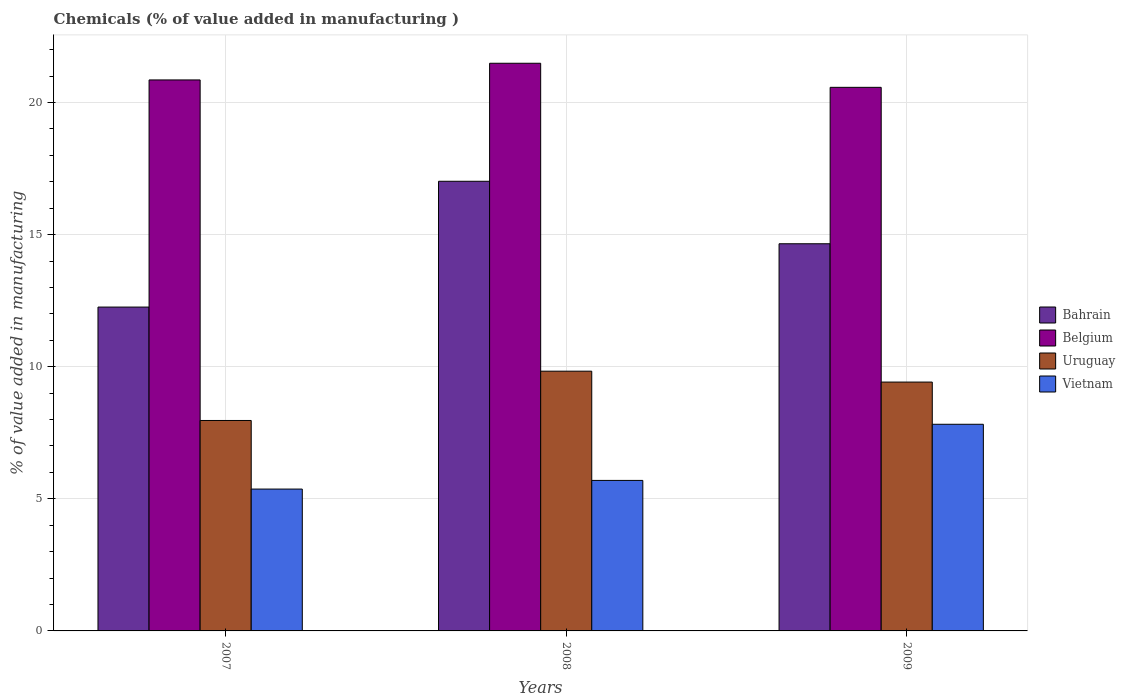How many groups of bars are there?
Your response must be concise. 3. Are the number of bars on each tick of the X-axis equal?
Keep it short and to the point. Yes. How many bars are there on the 1st tick from the left?
Keep it short and to the point. 4. What is the label of the 3rd group of bars from the left?
Offer a very short reply. 2009. What is the value added in manufacturing chemicals in Belgium in 2008?
Ensure brevity in your answer.  21.49. Across all years, what is the maximum value added in manufacturing chemicals in Vietnam?
Offer a very short reply. 7.82. Across all years, what is the minimum value added in manufacturing chemicals in Uruguay?
Your answer should be compact. 7.97. What is the total value added in manufacturing chemicals in Vietnam in the graph?
Offer a terse response. 18.89. What is the difference between the value added in manufacturing chemicals in Bahrain in 2008 and that in 2009?
Give a very brief answer. 2.36. What is the difference between the value added in manufacturing chemicals in Uruguay in 2008 and the value added in manufacturing chemicals in Vietnam in 2007?
Your answer should be compact. 4.46. What is the average value added in manufacturing chemicals in Vietnam per year?
Ensure brevity in your answer.  6.3. In the year 2009, what is the difference between the value added in manufacturing chemicals in Belgium and value added in manufacturing chemicals in Bahrain?
Offer a very short reply. 5.92. In how many years, is the value added in manufacturing chemicals in Bahrain greater than 15 %?
Make the answer very short. 1. What is the ratio of the value added in manufacturing chemicals in Vietnam in 2007 to that in 2009?
Ensure brevity in your answer.  0.69. What is the difference between the highest and the second highest value added in manufacturing chemicals in Vietnam?
Give a very brief answer. 2.13. What is the difference between the highest and the lowest value added in manufacturing chemicals in Belgium?
Give a very brief answer. 0.91. In how many years, is the value added in manufacturing chemicals in Vietnam greater than the average value added in manufacturing chemicals in Vietnam taken over all years?
Provide a succinct answer. 1. What does the 3rd bar from the left in 2007 represents?
Provide a short and direct response. Uruguay. How many bars are there?
Offer a terse response. 12. Are all the bars in the graph horizontal?
Your answer should be compact. No. What is the difference between two consecutive major ticks on the Y-axis?
Provide a succinct answer. 5. Are the values on the major ticks of Y-axis written in scientific E-notation?
Ensure brevity in your answer.  No. Does the graph contain any zero values?
Provide a succinct answer. No. Does the graph contain grids?
Your response must be concise. Yes. Where does the legend appear in the graph?
Keep it short and to the point. Center right. How many legend labels are there?
Your answer should be compact. 4. How are the legend labels stacked?
Provide a succinct answer. Vertical. What is the title of the graph?
Offer a terse response. Chemicals (% of value added in manufacturing ). Does "Chad" appear as one of the legend labels in the graph?
Provide a succinct answer. No. What is the label or title of the Y-axis?
Offer a very short reply. % of value added in manufacturing. What is the % of value added in manufacturing in Bahrain in 2007?
Offer a terse response. 12.26. What is the % of value added in manufacturing in Belgium in 2007?
Keep it short and to the point. 20.86. What is the % of value added in manufacturing in Uruguay in 2007?
Your answer should be compact. 7.97. What is the % of value added in manufacturing in Vietnam in 2007?
Your answer should be compact. 5.37. What is the % of value added in manufacturing of Bahrain in 2008?
Your answer should be very brief. 17.02. What is the % of value added in manufacturing in Belgium in 2008?
Provide a succinct answer. 21.49. What is the % of value added in manufacturing in Uruguay in 2008?
Make the answer very short. 9.83. What is the % of value added in manufacturing in Vietnam in 2008?
Your answer should be compact. 5.7. What is the % of value added in manufacturing of Bahrain in 2009?
Provide a succinct answer. 14.65. What is the % of value added in manufacturing in Belgium in 2009?
Give a very brief answer. 20.58. What is the % of value added in manufacturing of Uruguay in 2009?
Keep it short and to the point. 9.42. What is the % of value added in manufacturing of Vietnam in 2009?
Offer a very short reply. 7.82. Across all years, what is the maximum % of value added in manufacturing in Bahrain?
Keep it short and to the point. 17.02. Across all years, what is the maximum % of value added in manufacturing of Belgium?
Keep it short and to the point. 21.49. Across all years, what is the maximum % of value added in manufacturing of Uruguay?
Your answer should be compact. 9.83. Across all years, what is the maximum % of value added in manufacturing in Vietnam?
Ensure brevity in your answer.  7.82. Across all years, what is the minimum % of value added in manufacturing of Bahrain?
Your response must be concise. 12.26. Across all years, what is the minimum % of value added in manufacturing of Belgium?
Make the answer very short. 20.58. Across all years, what is the minimum % of value added in manufacturing of Uruguay?
Keep it short and to the point. 7.97. Across all years, what is the minimum % of value added in manufacturing in Vietnam?
Provide a short and direct response. 5.37. What is the total % of value added in manufacturing in Bahrain in the graph?
Ensure brevity in your answer.  43.93. What is the total % of value added in manufacturing in Belgium in the graph?
Provide a short and direct response. 62.92. What is the total % of value added in manufacturing in Uruguay in the graph?
Make the answer very short. 27.22. What is the total % of value added in manufacturing of Vietnam in the graph?
Make the answer very short. 18.89. What is the difference between the % of value added in manufacturing in Bahrain in 2007 and that in 2008?
Keep it short and to the point. -4.76. What is the difference between the % of value added in manufacturing of Belgium in 2007 and that in 2008?
Give a very brief answer. -0.63. What is the difference between the % of value added in manufacturing in Uruguay in 2007 and that in 2008?
Ensure brevity in your answer.  -1.87. What is the difference between the % of value added in manufacturing in Vietnam in 2007 and that in 2008?
Provide a succinct answer. -0.33. What is the difference between the % of value added in manufacturing in Bahrain in 2007 and that in 2009?
Provide a short and direct response. -2.4. What is the difference between the % of value added in manufacturing of Belgium in 2007 and that in 2009?
Make the answer very short. 0.28. What is the difference between the % of value added in manufacturing of Uruguay in 2007 and that in 2009?
Ensure brevity in your answer.  -1.45. What is the difference between the % of value added in manufacturing of Vietnam in 2007 and that in 2009?
Ensure brevity in your answer.  -2.45. What is the difference between the % of value added in manufacturing in Bahrain in 2008 and that in 2009?
Your response must be concise. 2.36. What is the difference between the % of value added in manufacturing in Belgium in 2008 and that in 2009?
Your answer should be very brief. 0.91. What is the difference between the % of value added in manufacturing in Uruguay in 2008 and that in 2009?
Provide a succinct answer. 0.41. What is the difference between the % of value added in manufacturing of Vietnam in 2008 and that in 2009?
Offer a very short reply. -2.13. What is the difference between the % of value added in manufacturing in Bahrain in 2007 and the % of value added in manufacturing in Belgium in 2008?
Your answer should be very brief. -9.23. What is the difference between the % of value added in manufacturing in Bahrain in 2007 and the % of value added in manufacturing in Uruguay in 2008?
Give a very brief answer. 2.43. What is the difference between the % of value added in manufacturing of Bahrain in 2007 and the % of value added in manufacturing of Vietnam in 2008?
Keep it short and to the point. 6.56. What is the difference between the % of value added in manufacturing in Belgium in 2007 and the % of value added in manufacturing in Uruguay in 2008?
Your answer should be very brief. 11.02. What is the difference between the % of value added in manufacturing of Belgium in 2007 and the % of value added in manufacturing of Vietnam in 2008?
Your answer should be very brief. 15.16. What is the difference between the % of value added in manufacturing in Uruguay in 2007 and the % of value added in manufacturing in Vietnam in 2008?
Your answer should be compact. 2.27. What is the difference between the % of value added in manufacturing in Bahrain in 2007 and the % of value added in manufacturing in Belgium in 2009?
Keep it short and to the point. -8.32. What is the difference between the % of value added in manufacturing of Bahrain in 2007 and the % of value added in manufacturing of Uruguay in 2009?
Your answer should be very brief. 2.84. What is the difference between the % of value added in manufacturing of Bahrain in 2007 and the % of value added in manufacturing of Vietnam in 2009?
Offer a very short reply. 4.44. What is the difference between the % of value added in manufacturing of Belgium in 2007 and the % of value added in manufacturing of Uruguay in 2009?
Your answer should be compact. 11.44. What is the difference between the % of value added in manufacturing of Belgium in 2007 and the % of value added in manufacturing of Vietnam in 2009?
Your answer should be compact. 13.03. What is the difference between the % of value added in manufacturing in Uruguay in 2007 and the % of value added in manufacturing in Vietnam in 2009?
Provide a short and direct response. 0.14. What is the difference between the % of value added in manufacturing of Bahrain in 2008 and the % of value added in manufacturing of Belgium in 2009?
Keep it short and to the point. -3.56. What is the difference between the % of value added in manufacturing in Bahrain in 2008 and the % of value added in manufacturing in Uruguay in 2009?
Keep it short and to the point. 7.6. What is the difference between the % of value added in manufacturing of Bahrain in 2008 and the % of value added in manufacturing of Vietnam in 2009?
Give a very brief answer. 9.2. What is the difference between the % of value added in manufacturing in Belgium in 2008 and the % of value added in manufacturing in Uruguay in 2009?
Keep it short and to the point. 12.07. What is the difference between the % of value added in manufacturing in Belgium in 2008 and the % of value added in manufacturing in Vietnam in 2009?
Your answer should be very brief. 13.66. What is the difference between the % of value added in manufacturing in Uruguay in 2008 and the % of value added in manufacturing in Vietnam in 2009?
Give a very brief answer. 2.01. What is the average % of value added in manufacturing of Bahrain per year?
Your answer should be very brief. 14.64. What is the average % of value added in manufacturing of Belgium per year?
Offer a terse response. 20.97. What is the average % of value added in manufacturing in Uruguay per year?
Your answer should be very brief. 9.07. What is the average % of value added in manufacturing in Vietnam per year?
Make the answer very short. 6.3. In the year 2007, what is the difference between the % of value added in manufacturing of Bahrain and % of value added in manufacturing of Belgium?
Your answer should be very brief. -8.6. In the year 2007, what is the difference between the % of value added in manufacturing in Bahrain and % of value added in manufacturing in Uruguay?
Give a very brief answer. 4.29. In the year 2007, what is the difference between the % of value added in manufacturing in Bahrain and % of value added in manufacturing in Vietnam?
Your response must be concise. 6.89. In the year 2007, what is the difference between the % of value added in manufacturing in Belgium and % of value added in manufacturing in Uruguay?
Your answer should be compact. 12.89. In the year 2007, what is the difference between the % of value added in manufacturing of Belgium and % of value added in manufacturing of Vietnam?
Ensure brevity in your answer.  15.49. In the year 2007, what is the difference between the % of value added in manufacturing in Uruguay and % of value added in manufacturing in Vietnam?
Offer a terse response. 2.6. In the year 2008, what is the difference between the % of value added in manufacturing of Bahrain and % of value added in manufacturing of Belgium?
Provide a succinct answer. -4.47. In the year 2008, what is the difference between the % of value added in manufacturing in Bahrain and % of value added in manufacturing in Uruguay?
Make the answer very short. 7.19. In the year 2008, what is the difference between the % of value added in manufacturing in Bahrain and % of value added in manufacturing in Vietnam?
Ensure brevity in your answer.  11.32. In the year 2008, what is the difference between the % of value added in manufacturing of Belgium and % of value added in manufacturing of Uruguay?
Your answer should be compact. 11.66. In the year 2008, what is the difference between the % of value added in manufacturing in Belgium and % of value added in manufacturing in Vietnam?
Your answer should be very brief. 15.79. In the year 2008, what is the difference between the % of value added in manufacturing in Uruguay and % of value added in manufacturing in Vietnam?
Provide a succinct answer. 4.13. In the year 2009, what is the difference between the % of value added in manufacturing of Bahrain and % of value added in manufacturing of Belgium?
Your answer should be very brief. -5.92. In the year 2009, what is the difference between the % of value added in manufacturing of Bahrain and % of value added in manufacturing of Uruguay?
Your answer should be very brief. 5.24. In the year 2009, what is the difference between the % of value added in manufacturing of Bahrain and % of value added in manufacturing of Vietnam?
Give a very brief answer. 6.83. In the year 2009, what is the difference between the % of value added in manufacturing of Belgium and % of value added in manufacturing of Uruguay?
Ensure brevity in your answer.  11.16. In the year 2009, what is the difference between the % of value added in manufacturing of Belgium and % of value added in manufacturing of Vietnam?
Offer a very short reply. 12.75. In the year 2009, what is the difference between the % of value added in manufacturing in Uruguay and % of value added in manufacturing in Vietnam?
Your answer should be compact. 1.6. What is the ratio of the % of value added in manufacturing of Bahrain in 2007 to that in 2008?
Your response must be concise. 0.72. What is the ratio of the % of value added in manufacturing of Belgium in 2007 to that in 2008?
Your response must be concise. 0.97. What is the ratio of the % of value added in manufacturing in Uruguay in 2007 to that in 2008?
Your response must be concise. 0.81. What is the ratio of the % of value added in manufacturing of Vietnam in 2007 to that in 2008?
Make the answer very short. 0.94. What is the ratio of the % of value added in manufacturing in Bahrain in 2007 to that in 2009?
Keep it short and to the point. 0.84. What is the ratio of the % of value added in manufacturing of Belgium in 2007 to that in 2009?
Keep it short and to the point. 1.01. What is the ratio of the % of value added in manufacturing in Uruguay in 2007 to that in 2009?
Give a very brief answer. 0.85. What is the ratio of the % of value added in manufacturing of Vietnam in 2007 to that in 2009?
Your answer should be very brief. 0.69. What is the ratio of the % of value added in manufacturing of Bahrain in 2008 to that in 2009?
Provide a succinct answer. 1.16. What is the ratio of the % of value added in manufacturing of Belgium in 2008 to that in 2009?
Offer a very short reply. 1.04. What is the ratio of the % of value added in manufacturing of Uruguay in 2008 to that in 2009?
Your answer should be very brief. 1.04. What is the ratio of the % of value added in manufacturing in Vietnam in 2008 to that in 2009?
Offer a very short reply. 0.73. What is the difference between the highest and the second highest % of value added in manufacturing of Bahrain?
Your answer should be very brief. 2.36. What is the difference between the highest and the second highest % of value added in manufacturing in Belgium?
Your response must be concise. 0.63. What is the difference between the highest and the second highest % of value added in manufacturing in Uruguay?
Your response must be concise. 0.41. What is the difference between the highest and the second highest % of value added in manufacturing in Vietnam?
Ensure brevity in your answer.  2.13. What is the difference between the highest and the lowest % of value added in manufacturing in Bahrain?
Give a very brief answer. 4.76. What is the difference between the highest and the lowest % of value added in manufacturing in Belgium?
Your answer should be very brief. 0.91. What is the difference between the highest and the lowest % of value added in manufacturing of Uruguay?
Provide a short and direct response. 1.87. What is the difference between the highest and the lowest % of value added in manufacturing of Vietnam?
Keep it short and to the point. 2.45. 